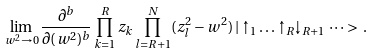Convert formula to latex. <formula><loc_0><loc_0><loc_500><loc_500>\lim _ { w ^ { 2 } \rightarrow 0 } \frac { \partial ^ { b } } { \partial ( w ^ { 2 } ) ^ { b } } \prod _ { k = 1 } ^ { R } z _ { k } \prod _ { l = R + 1 } ^ { N } ( z _ { l } ^ { 2 } - w ^ { 2 } ) \, | \uparrow _ { 1 } \dots \uparrow _ { R } \downarrow _ { R + 1 } \dots > \, .</formula> 